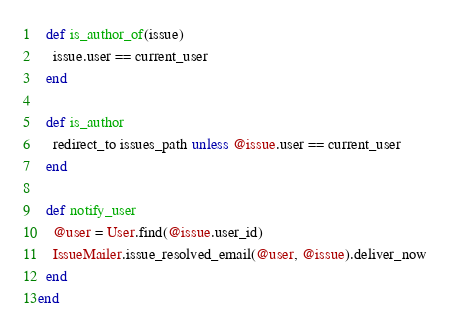<code> <loc_0><loc_0><loc_500><loc_500><_Ruby_>  def is_author_of(issue)
    issue.user == current_user
  end

  def is_author
    redirect_to issues_path unless @issue.user == current_user
  end

  def notify_user
    @user = User.find(@issue.user_id)
    IssueMailer.issue_resolved_email(@user, @issue).deliver_now
  end
end
</code> 